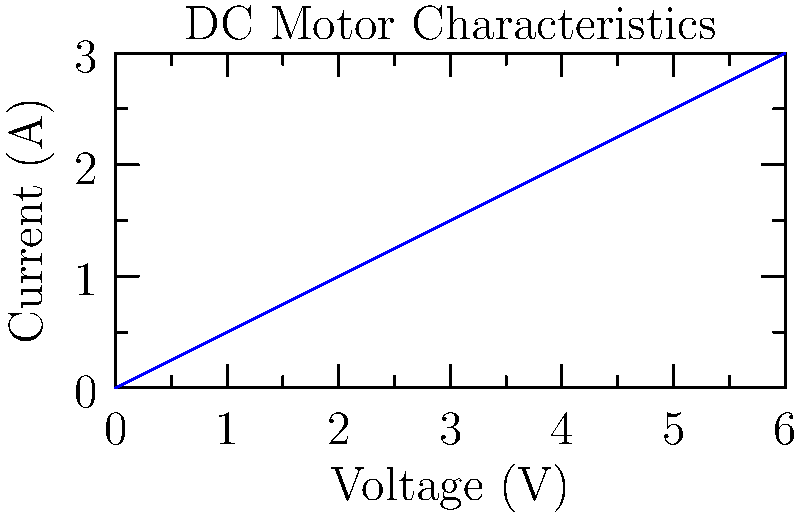Your parents recently bought you a small DC motor for a science project to help take your mind off their divorce. The motor's characteristics are shown in the graph above. If the motor is operating at 4V, what is its power output? How might understanding this concept help you feel more in control during this difficult time? Let's approach this step-by-step:

1) First, we need to understand that power in a DC circuit is given by the equation:

   $$P = V \times I$$

   Where $P$ is power in watts, $V$ is voltage in volts, and $I$ is current in amperes.

2) From the graph, we can see that when the voltage is 4V, the corresponding current is 2A.

3) Now, we can plug these values into our power equation:

   $$P = 4V \times 2A = 8W$$

4) Therefore, the power output of the motor at 4V is 8 watts.

Understanding this concept can help you feel more in control by:
- Providing a sense of predictability in a time of uncertainty
- Allowing you to focus on concrete, solvable problems
- Giving you a small win and boost of confidence in your abilities
Answer: 8 watts 